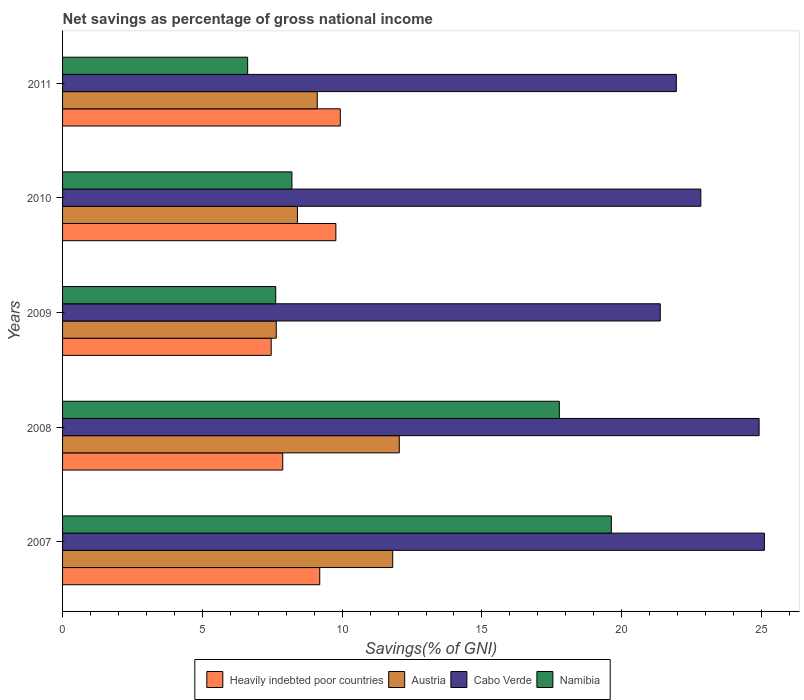How many different coloured bars are there?
Offer a very short reply. 4. Are the number of bars on each tick of the Y-axis equal?
Keep it short and to the point. Yes. How many bars are there on the 5th tick from the bottom?
Offer a very short reply. 4. What is the total savings in Cabo Verde in 2007?
Your answer should be compact. 25.1. Across all years, what is the maximum total savings in Namibia?
Make the answer very short. 19.63. Across all years, what is the minimum total savings in Heavily indebted poor countries?
Your answer should be compact. 7.46. What is the total total savings in Cabo Verde in the graph?
Keep it short and to the point. 116.18. What is the difference between the total savings in Cabo Verde in 2008 and that in 2009?
Keep it short and to the point. 3.54. What is the difference between the total savings in Cabo Verde in 2009 and the total savings in Austria in 2011?
Your answer should be compact. 12.27. What is the average total savings in Cabo Verde per year?
Offer a terse response. 23.24. In the year 2009, what is the difference between the total savings in Austria and total savings in Heavily indebted poor countries?
Your answer should be very brief. 0.18. In how many years, is the total savings in Heavily indebted poor countries greater than 4 %?
Provide a short and direct response. 5. What is the ratio of the total savings in Heavily indebted poor countries in 2007 to that in 2009?
Ensure brevity in your answer.  1.23. What is the difference between the highest and the second highest total savings in Heavily indebted poor countries?
Make the answer very short. 0.16. What is the difference between the highest and the lowest total savings in Namibia?
Make the answer very short. 13.01. Is the sum of the total savings in Cabo Verde in 2008 and 2009 greater than the maximum total savings in Austria across all years?
Your answer should be compact. Yes. Is it the case that in every year, the sum of the total savings in Austria and total savings in Cabo Verde is greater than the sum of total savings in Heavily indebted poor countries and total savings in Namibia?
Provide a succinct answer. Yes. What does the 2nd bar from the bottom in 2011 represents?
Ensure brevity in your answer.  Austria. How many bars are there?
Offer a very short reply. 20. Does the graph contain any zero values?
Provide a succinct answer. No. Does the graph contain grids?
Keep it short and to the point. No. How are the legend labels stacked?
Keep it short and to the point. Horizontal. What is the title of the graph?
Offer a very short reply. Net savings as percentage of gross national income. Does "Other small states" appear as one of the legend labels in the graph?
Provide a short and direct response. No. What is the label or title of the X-axis?
Your answer should be very brief. Savings(% of GNI). What is the label or title of the Y-axis?
Your answer should be compact. Years. What is the Savings(% of GNI) of Heavily indebted poor countries in 2007?
Offer a very short reply. 9.2. What is the Savings(% of GNI) of Austria in 2007?
Make the answer very short. 11.81. What is the Savings(% of GNI) of Cabo Verde in 2007?
Your answer should be very brief. 25.1. What is the Savings(% of GNI) of Namibia in 2007?
Offer a very short reply. 19.63. What is the Savings(% of GNI) of Heavily indebted poor countries in 2008?
Offer a terse response. 7.87. What is the Savings(% of GNI) in Austria in 2008?
Your answer should be compact. 12.04. What is the Savings(% of GNI) of Cabo Verde in 2008?
Give a very brief answer. 24.91. What is the Savings(% of GNI) of Namibia in 2008?
Keep it short and to the point. 17.77. What is the Savings(% of GNI) in Heavily indebted poor countries in 2009?
Offer a terse response. 7.46. What is the Savings(% of GNI) of Austria in 2009?
Your answer should be very brief. 7.64. What is the Savings(% of GNI) in Cabo Verde in 2009?
Offer a terse response. 21.38. What is the Savings(% of GNI) of Namibia in 2009?
Ensure brevity in your answer.  7.62. What is the Savings(% of GNI) of Heavily indebted poor countries in 2010?
Your answer should be very brief. 9.78. What is the Savings(% of GNI) of Austria in 2010?
Ensure brevity in your answer.  8.4. What is the Savings(% of GNI) of Cabo Verde in 2010?
Give a very brief answer. 22.83. What is the Savings(% of GNI) of Namibia in 2010?
Keep it short and to the point. 8.2. What is the Savings(% of GNI) of Heavily indebted poor countries in 2011?
Give a very brief answer. 9.93. What is the Savings(% of GNI) of Austria in 2011?
Offer a terse response. 9.11. What is the Savings(% of GNI) in Cabo Verde in 2011?
Ensure brevity in your answer.  21.95. What is the Savings(% of GNI) in Namibia in 2011?
Keep it short and to the point. 6.62. Across all years, what is the maximum Savings(% of GNI) in Heavily indebted poor countries?
Offer a very short reply. 9.93. Across all years, what is the maximum Savings(% of GNI) in Austria?
Offer a terse response. 12.04. Across all years, what is the maximum Savings(% of GNI) of Cabo Verde?
Offer a very short reply. 25.1. Across all years, what is the maximum Savings(% of GNI) in Namibia?
Your answer should be very brief. 19.63. Across all years, what is the minimum Savings(% of GNI) of Heavily indebted poor countries?
Your answer should be very brief. 7.46. Across all years, what is the minimum Savings(% of GNI) of Austria?
Give a very brief answer. 7.64. Across all years, what is the minimum Savings(% of GNI) of Cabo Verde?
Your answer should be compact. 21.38. Across all years, what is the minimum Savings(% of GNI) in Namibia?
Your answer should be compact. 6.62. What is the total Savings(% of GNI) in Heavily indebted poor countries in the graph?
Your response must be concise. 44.25. What is the total Savings(% of GNI) in Austria in the graph?
Provide a succinct answer. 49.01. What is the total Savings(% of GNI) in Cabo Verde in the graph?
Provide a short and direct response. 116.18. What is the total Savings(% of GNI) in Namibia in the graph?
Provide a short and direct response. 59.85. What is the difference between the Savings(% of GNI) in Heavily indebted poor countries in 2007 and that in 2008?
Ensure brevity in your answer.  1.32. What is the difference between the Savings(% of GNI) in Austria in 2007 and that in 2008?
Keep it short and to the point. -0.24. What is the difference between the Savings(% of GNI) in Cabo Verde in 2007 and that in 2008?
Provide a succinct answer. 0.19. What is the difference between the Savings(% of GNI) in Namibia in 2007 and that in 2008?
Provide a short and direct response. 1.86. What is the difference between the Savings(% of GNI) of Heavily indebted poor countries in 2007 and that in 2009?
Offer a terse response. 1.74. What is the difference between the Savings(% of GNI) of Austria in 2007 and that in 2009?
Give a very brief answer. 4.16. What is the difference between the Savings(% of GNI) in Cabo Verde in 2007 and that in 2009?
Offer a terse response. 3.72. What is the difference between the Savings(% of GNI) of Namibia in 2007 and that in 2009?
Make the answer very short. 12. What is the difference between the Savings(% of GNI) in Heavily indebted poor countries in 2007 and that in 2010?
Ensure brevity in your answer.  -0.58. What is the difference between the Savings(% of GNI) of Austria in 2007 and that in 2010?
Provide a short and direct response. 3.41. What is the difference between the Savings(% of GNI) in Cabo Verde in 2007 and that in 2010?
Make the answer very short. 2.27. What is the difference between the Savings(% of GNI) in Namibia in 2007 and that in 2010?
Give a very brief answer. 11.43. What is the difference between the Savings(% of GNI) of Heavily indebted poor countries in 2007 and that in 2011?
Your answer should be very brief. -0.73. What is the difference between the Savings(% of GNI) in Austria in 2007 and that in 2011?
Provide a succinct answer. 2.7. What is the difference between the Savings(% of GNI) in Cabo Verde in 2007 and that in 2011?
Provide a succinct answer. 3.15. What is the difference between the Savings(% of GNI) in Namibia in 2007 and that in 2011?
Your answer should be very brief. 13.01. What is the difference between the Savings(% of GNI) of Heavily indebted poor countries in 2008 and that in 2009?
Provide a succinct answer. 0.41. What is the difference between the Savings(% of GNI) of Austria in 2008 and that in 2009?
Make the answer very short. 4.4. What is the difference between the Savings(% of GNI) of Cabo Verde in 2008 and that in 2009?
Provide a succinct answer. 3.54. What is the difference between the Savings(% of GNI) in Namibia in 2008 and that in 2009?
Provide a short and direct response. 10.14. What is the difference between the Savings(% of GNI) in Heavily indebted poor countries in 2008 and that in 2010?
Provide a succinct answer. -1.9. What is the difference between the Savings(% of GNI) in Austria in 2008 and that in 2010?
Provide a short and direct response. 3.64. What is the difference between the Savings(% of GNI) of Cabo Verde in 2008 and that in 2010?
Give a very brief answer. 2.08. What is the difference between the Savings(% of GNI) in Namibia in 2008 and that in 2010?
Ensure brevity in your answer.  9.57. What is the difference between the Savings(% of GNI) in Heavily indebted poor countries in 2008 and that in 2011?
Make the answer very short. -2.06. What is the difference between the Savings(% of GNI) in Austria in 2008 and that in 2011?
Your answer should be very brief. 2.94. What is the difference between the Savings(% of GNI) in Cabo Verde in 2008 and that in 2011?
Provide a short and direct response. 2.96. What is the difference between the Savings(% of GNI) in Namibia in 2008 and that in 2011?
Your answer should be compact. 11.15. What is the difference between the Savings(% of GNI) in Heavily indebted poor countries in 2009 and that in 2010?
Give a very brief answer. -2.31. What is the difference between the Savings(% of GNI) in Austria in 2009 and that in 2010?
Provide a short and direct response. -0.76. What is the difference between the Savings(% of GNI) of Cabo Verde in 2009 and that in 2010?
Provide a succinct answer. -1.45. What is the difference between the Savings(% of GNI) of Namibia in 2009 and that in 2010?
Provide a short and direct response. -0.58. What is the difference between the Savings(% of GNI) of Heavily indebted poor countries in 2009 and that in 2011?
Your response must be concise. -2.47. What is the difference between the Savings(% of GNI) of Austria in 2009 and that in 2011?
Your answer should be compact. -1.47. What is the difference between the Savings(% of GNI) in Cabo Verde in 2009 and that in 2011?
Ensure brevity in your answer.  -0.57. What is the difference between the Savings(% of GNI) of Namibia in 2009 and that in 2011?
Your answer should be compact. 1. What is the difference between the Savings(% of GNI) in Heavily indebted poor countries in 2010 and that in 2011?
Provide a succinct answer. -0.16. What is the difference between the Savings(% of GNI) of Austria in 2010 and that in 2011?
Provide a succinct answer. -0.71. What is the difference between the Savings(% of GNI) in Cabo Verde in 2010 and that in 2011?
Keep it short and to the point. 0.88. What is the difference between the Savings(% of GNI) in Namibia in 2010 and that in 2011?
Offer a terse response. 1.58. What is the difference between the Savings(% of GNI) of Heavily indebted poor countries in 2007 and the Savings(% of GNI) of Austria in 2008?
Provide a short and direct response. -2.84. What is the difference between the Savings(% of GNI) of Heavily indebted poor countries in 2007 and the Savings(% of GNI) of Cabo Verde in 2008?
Your answer should be very brief. -15.72. What is the difference between the Savings(% of GNI) of Heavily indebted poor countries in 2007 and the Savings(% of GNI) of Namibia in 2008?
Make the answer very short. -8.57. What is the difference between the Savings(% of GNI) in Austria in 2007 and the Savings(% of GNI) in Cabo Verde in 2008?
Offer a very short reply. -13.11. What is the difference between the Savings(% of GNI) of Austria in 2007 and the Savings(% of GNI) of Namibia in 2008?
Offer a very short reply. -5.96. What is the difference between the Savings(% of GNI) of Cabo Verde in 2007 and the Savings(% of GNI) of Namibia in 2008?
Your response must be concise. 7.33. What is the difference between the Savings(% of GNI) in Heavily indebted poor countries in 2007 and the Savings(% of GNI) in Austria in 2009?
Keep it short and to the point. 1.56. What is the difference between the Savings(% of GNI) in Heavily indebted poor countries in 2007 and the Savings(% of GNI) in Cabo Verde in 2009?
Provide a short and direct response. -12.18. What is the difference between the Savings(% of GNI) of Heavily indebted poor countries in 2007 and the Savings(% of GNI) of Namibia in 2009?
Make the answer very short. 1.57. What is the difference between the Savings(% of GNI) in Austria in 2007 and the Savings(% of GNI) in Cabo Verde in 2009?
Give a very brief answer. -9.57. What is the difference between the Savings(% of GNI) of Austria in 2007 and the Savings(% of GNI) of Namibia in 2009?
Your response must be concise. 4.18. What is the difference between the Savings(% of GNI) in Cabo Verde in 2007 and the Savings(% of GNI) in Namibia in 2009?
Provide a succinct answer. 17.48. What is the difference between the Savings(% of GNI) of Heavily indebted poor countries in 2007 and the Savings(% of GNI) of Austria in 2010?
Your answer should be compact. 0.8. What is the difference between the Savings(% of GNI) of Heavily indebted poor countries in 2007 and the Savings(% of GNI) of Cabo Verde in 2010?
Offer a terse response. -13.63. What is the difference between the Savings(% of GNI) of Heavily indebted poor countries in 2007 and the Savings(% of GNI) of Namibia in 2010?
Your answer should be very brief. 1. What is the difference between the Savings(% of GNI) of Austria in 2007 and the Savings(% of GNI) of Cabo Verde in 2010?
Make the answer very short. -11.02. What is the difference between the Savings(% of GNI) in Austria in 2007 and the Savings(% of GNI) in Namibia in 2010?
Provide a succinct answer. 3.6. What is the difference between the Savings(% of GNI) in Cabo Verde in 2007 and the Savings(% of GNI) in Namibia in 2010?
Keep it short and to the point. 16.9. What is the difference between the Savings(% of GNI) of Heavily indebted poor countries in 2007 and the Savings(% of GNI) of Austria in 2011?
Ensure brevity in your answer.  0.09. What is the difference between the Savings(% of GNI) of Heavily indebted poor countries in 2007 and the Savings(% of GNI) of Cabo Verde in 2011?
Offer a terse response. -12.75. What is the difference between the Savings(% of GNI) of Heavily indebted poor countries in 2007 and the Savings(% of GNI) of Namibia in 2011?
Provide a succinct answer. 2.58. What is the difference between the Savings(% of GNI) of Austria in 2007 and the Savings(% of GNI) of Cabo Verde in 2011?
Provide a short and direct response. -10.14. What is the difference between the Savings(% of GNI) in Austria in 2007 and the Savings(% of GNI) in Namibia in 2011?
Your answer should be compact. 5.19. What is the difference between the Savings(% of GNI) in Cabo Verde in 2007 and the Savings(% of GNI) in Namibia in 2011?
Ensure brevity in your answer.  18.48. What is the difference between the Savings(% of GNI) in Heavily indebted poor countries in 2008 and the Savings(% of GNI) in Austria in 2009?
Your response must be concise. 0.23. What is the difference between the Savings(% of GNI) in Heavily indebted poor countries in 2008 and the Savings(% of GNI) in Cabo Verde in 2009?
Make the answer very short. -13.5. What is the difference between the Savings(% of GNI) of Heavily indebted poor countries in 2008 and the Savings(% of GNI) of Namibia in 2009?
Provide a succinct answer. 0.25. What is the difference between the Savings(% of GNI) of Austria in 2008 and the Savings(% of GNI) of Cabo Verde in 2009?
Your answer should be compact. -9.33. What is the difference between the Savings(% of GNI) in Austria in 2008 and the Savings(% of GNI) in Namibia in 2009?
Keep it short and to the point. 4.42. What is the difference between the Savings(% of GNI) of Cabo Verde in 2008 and the Savings(% of GNI) of Namibia in 2009?
Offer a terse response. 17.29. What is the difference between the Savings(% of GNI) of Heavily indebted poor countries in 2008 and the Savings(% of GNI) of Austria in 2010?
Keep it short and to the point. -0.53. What is the difference between the Savings(% of GNI) of Heavily indebted poor countries in 2008 and the Savings(% of GNI) of Cabo Verde in 2010?
Your answer should be compact. -14.95. What is the difference between the Savings(% of GNI) of Heavily indebted poor countries in 2008 and the Savings(% of GNI) of Namibia in 2010?
Offer a terse response. -0.33. What is the difference between the Savings(% of GNI) in Austria in 2008 and the Savings(% of GNI) in Cabo Verde in 2010?
Ensure brevity in your answer.  -10.79. What is the difference between the Savings(% of GNI) of Austria in 2008 and the Savings(% of GNI) of Namibia in 2010?
Keep it short and to the point. 3.84. What is the difference between the Savings(% of GNI) in Cabo Verde in 2008 and the Savings(% of GNI) in Namibia in 2010?
Your answer should be very brief. 16.71. What is the difference between the Savings(% of GNI) of Heavily indebted poor countries in 2008 and the Savings(% of GNI) of Austria in 2011?
Keep it short and to the point. -1.23. What is the difference between the Savings(% of GNI) of Heavily indebted poor countries in 2008 and the Savings(% of GNI) of Cabo Verde in 2011?
Your response must be concise. -14.08. What is the difference between the Savings(% of GNI) of Heavily indebted poor countries in 2008 and the Savings(% of GNI) of Namibia in 2011?
Ensure brevity in your answer.  1.25. What is the difference between the Savings(% of GNI) of Austria in 2008 and the Savings(% of GNI) of Cabo Verde in 2011?
Give a very brief answer. -9.91. What is the difference between the Savings(% of GNI) of Austria in 2008 and the Savings(% of GNI) of Namibia in 2011?
Offer a terse response. 5.42. What is the difference between the Savings(% of GNI) of Cabo Verde in 2008 and the Savings(% of GNI) of Namibia in 2011?
Provide a short and direct response. 18.29. What is the difference between the Savings(% of GNI) of Heavily indebted poor countries in 2009 and the Savings(% of GNI) of Austria in 2010?
Ensure brevity in your answer.  -0.94. What is the difference between the Savings(% of GNI) of Heavily indebted poor countries in 2009 and the Savings(% of GNI) of Cabo Verde in 2010?
Make the answer very short. -15.37. What is the difference between the Savings(% of GNI) in Heavily indebted poor countries in 2009 and the Savings(% of GNI) in Namibia in 2010?
Your answer should be compact. -0.74. What is the difference between the Savings(% of GNI) in Austria in 2009 and the Savings(% of GNI) in Cabo Verde in 2010?
Your response must be concise. -15.19. What is the difference between the Savings(% of GNI) in Austria in 2009 and the Savings(% of GNI) in Namibia in 2010?
Provide a short and direct response. -0.56. What is the difference between the Savings(% of GNI) in Cabo Verde in 2009 and the Savings(% of GNI) in Namibia in 2010?
Your answer should be very brief. 13.18. What is the difference between the Savings(% of GNI) of Heavily indebted poor countries in 2009 and the Savings(% of GNI) of Austria in 2011?
Make the answer very short. -1.65. What is the difference between the Savings(% of GNI) of Heavily indebted poor countries in 2009 and the Savings(% of GNI) of Cabo Verde in 2011?
Offer a terse response. -14.49. What is the difference between the Savings(% of GNI) of Heavily indebted poor countries in 2009 and the Savings(% of GNI) of Namibia in 2011?
Provide a succinct answer. 0.84. What is the difference between the Savings(% of GNI) of Austria in 2009 and the Savings(% of GNI) of Cabo Verde in 2011?
Give a very brief answer. -14.31. What is the difference between the Savings(% of GNI) in Austria in 2009 and the Savings(% of GNI) in Namibia in 2011?
Offer a very short reply. 1.02. What is the difference between the Savings(% of GNI) of Cabo Verde in 2009 and the Savings(% of GNI) of Namibia in 2011?
Provide a succinct answer. 14.76. What is the difference between the Savings(% of GNI) in Heavily indebted poor countries in 2010 and the Savings(% of GNI) in Austria in 2011?
Provide a succinct answer. 0.67. What is the difference between the Savings(% of GNI) in Heavily indebted poor countries in 2010 and the Savings(% of GNI) in Cabo Verde in 2011?
Your answer should be compact. -12.18. What is the difference between the Savings(% of GNI) of Heavily indebted poor countries in 2010 and the Savings(% of GNI) of Namibia in 2011?
Give a very brief answer. 3.16. What is the difference between the Savings(% of GNI) of Austria in 2010 and the Savings(% of GNI) of Cabo Verde in 2011?
Offer a terse response. -13.55. What is the difference between the Savings(% of GNI) in Austria in 2010 and the Savings(% of GNI) in Namibia in 2011?
Make the answer very short. 1.78. What is the difference between the Savings(% of GNI) of Cabo Verde in 2010 and the Savings(% of GNI) of Namibia in 2011?
Your response must be concise. 16.21. What is the average Savings(% of GNI) of Heavily indebted poor countries per year?
Ensure brevity in your answer.  8.85. What is the average Savings(% of GNI) in Austria per year?
Make the answer very short. 9.8. What is the average Savings(% of GNI) of Cabo Verde per year?
Offer a very short reply. 23.24. What is the average Savings(% of GNI) of Namibia per year?
Provide a short and direct response. 11.97. In the year 2007, what is the difference between the Savings(% of GNI) in Heavily indebted poor countries and Savings(% of GNI) in Austria?
Ensure brevity in your answer.  -2.61. In the year 2007, what is the difference between the Savings(% of GNI) of Heavily indebted poor countries and Savings(% of GNI) of Cabo Verde?
Make the answer very short. -15.9. In the year 2007, what is the difference between the Savings(% of GNI) in Heavily indebted poor countries and Savings(% of GNI) in Namibia?
Provide a short and direct response. -10.43. In the year 2007, what is the difference between the Savings(% of GNI) in Austria and Savings(% of GNI) in Cabo Verde?
Your response must be concise. -13.3. In the year 2007, what is the difference between the Savings(% of GNI) in Austria and Savings(% of GNI) in Namibia?
Give a very brief answer. -7.82. In the year 2007, what is the difference between the Savings(% of GNI) in Cabo Verde and Savings(% of GNI) in Namibia?
Make the answer very short. 5.47. In the year 2008, what is the difference between the Savings(% of GNI) of Heavily indebted poor countries and Savings(% of GNI) of Austria?
Keep it short and to the point. -4.17. In the year 2008, what is the difference between the Savings(% of GNI) in Heavily indebted poor countries and Savings(% of GNI) in Cabo Verde?
Give a very brief answer. -17.04. In the year 2008, what is the difference between the Savings(% of GNI) of Heavily indebted poor countries and Savings(% of GNI) of Namibia?
Provide a short and direct response. -9.89. In the year 2008, what is the difference between the Savings(% of GNI) in Austria and Savings(% of GNI) in Cabo Verde?
Your answer should be very brief. -12.87. In the year 2008, what is the difference between the Savings(% of GNI) in Austria and Savings(% of GNI) in Namibia?
Ensure brevity in your answer.  -5.73. In the year 2008, what is the difference between the Savings(% of GNI) of Cabo Verde and Savings(% of GNI) of Namibia?
Offer a very short reply. 7.15. In the year 2009, what is the difference between the Savings(% of GNI) of Heavily indebted poor countries and Savings(% of GNI) of Austria?
Your answer should be very brief. -0.18. In the year 2009, what is the difference between the Savings(% of GNI) in Heavily indebted poor countries and Savings(% of GNI) in Cabo Verde?
Offer a very short reply. -13.92. In the year 2009, what is the difference between the Savings(% of GNI) in Heavily indebted poor countries and Savings(% of GNI) in Namibia?
Your answer should be compact. -0.16. In the year 2009, what is the difference between the Savings(% of GNI) of Austria and Savings(% of GNI) of Cabo Verde?
Give a very brief answer. -13.74. In the year 2009, what is the difference between the Savings(% of GNI) of Austria and Savings(% of GNI) of Namibia?
Give a very brief answer. 0.02. In the year 2009, what is the difference between the Savings(% of GNI) of Cabo Verde and Savings(% of GNI) of Namibia?
Make the answer very short. 13.75. In the year 2010, what is the difference between the Savings(% of GNI) in Heavily indebted poor countries and Savings(% of GNI) in Austria?
Your answer should be very brief. 1.37. In the year 2010, what is the difference between the Savings(% of GNI) of Heavily indebted poor countries and Savings(% of GNI) of Cabo Verde?
Ensure brevity in your answer.  -13.05. In the year 2010, what is the difference between the Savings(% of GNI) in Heavily indebted poor countries and Savings(% of GNI) in Namibia?
Your answer should be very brief. 1.57. In the year 2010, what is the difference between the Savings(% of GNI) of Austria and Savings(% of GNI) of Cabo Verde?
Offer a terse response. -14.43. In the year 2010, what is the difference between the Savings(% of GNI) of Austria and Savings(% of GNI) of Namibia?
Make the answer very short. 0.2. In the year 2010, what is the difference between the Savings(% of GNI) in Cabo Verde and Savings(% of GNI) in Namibia?
Your answer should be compact. 14.63. In the year 2011, what is the difference between the Savings(% of GNI) of Heavily indebted poor countries and Savings(% of GNI) of Austria?
Make the answer very short. 0.82. In the year 2011, what is the difference between the Savings(% of GNI) in Heavily indebted poor countries and Savings(% of GNI) in Cabo Verde?
Ensure brevity in your answer.  -12.02. In the year 2011, what is the difference between the Savings(% of GNI) in Heavily indebted poor countries and Savings(% of GNI) in Namibia?
Your answer should be compact. 3.31. In the year 2011, what is the difference between the Savings(% of GNI) of Austria and Savings(% of GNI) of Cabo Verde?
Your answer should be compact. -12.84. In the year 2011, what is the difference between the Savings(% of GNI) of Austria and Savings(% of GNI) of Namibia?
Make the answer very short. 2.49. In the year 2011, what is the difference between the Savings(% of GNI) of Cabo Verde and Savings(% of GNI) of Namibia?
Provide a short and direct response. 15.33. What is the ratio of the Savings(% of GNI) of Heavily indebted poor countries in 2007 to that in 2008?
Ensure brevity in your answer.  1.17. What is the ratio of the Savings(% of GNI) of Austria in 2007 to that in 2008?
Offer a terse response. 0.98. What is the ratio of the Savings(% of GNI) of Cabo Verde in 2007 to that in 2008?
Make the answer very short. 1.01. What is the ratio of the Savings(% of GNI) of Namibia in 2007 to that in 2008?
Your answer should be very brief. 1.1. What is the ratio of the Savings(% of GNI) in Heavily indebted poor countries in 2007 to that in 2009?
Your answer should be very brief. 1.23. What is the ratio of the Savings(% of GNI) of Austria in 2007 to that in 2009?
Ensure brevity in your answer.  1.54. What is the ratio of the Savings(% of GNI) in Cabo Verde in 2007 to that in 2009?
Provide a short and direct response. 1.17. What is the ratio of the Savings(% of GNI) in Namibia in 2007 to that in 2009?
Your answer should be compact. 2.57. What is the ratio of the Savings(% of GNI) of Heavily indebted poor countries in 2007 to that in 2010?
Provide a short and direct response. 0.94. What is the ratio of the Savings(% of GNI) in Austria in 2007 to that in 2010?
Your answer should be very brief. 1.41. What is the ratio of the Savings(% of GNI) of Cabo Verde in 2007 to that in 2010?
Provide a succinct answer. 1.1. What is the ratio of the Savings(% of GNI) in Namibia in 2007 to that in 2010?
Your answer should be very brief. 2.39. What is the ratio of the Savings(% of GNI) of Heavily indebted poor countries in 2007 to that in 2011?
Make the answer very short. 0.93. What is the ratio of the Savings(% of GNI) of Austria in 2007 to that in 2011?
Offer a terse response. 1.3. What is the ratio of the Savings(% of GNI) in Cabo Verde in 2007 to that in 2011?
Make the answer very short. 1.14. What is the ratio of the Savings(% of GNI) in Namibia in 2007 to that in 2011?
Ensure brevity in your answer.  2.96. What is the ratio of the Savings(% of GNI) in Heavily indebted poor countries in 2008 to that in 2009?
Ensure brevity in your answer.  1.06. What is the ratio of the Savings(% of GNI) in Austria in 2008 to that in 2009?
Your response must be concise. 1.58. What is the ratio of the Savings(% of GNI) in Cabo Verde in 2008 to that in 2009?
Your answer should be compact. 1.17. What is the ratio of the Savings(% of GNI) of Namibia in 2008 to that in 2009?
Make the answer very short. 2.33. What is the ratio of the Savings(% of GNI) in Heavily indebted poor countries in 2008 to that in 2010?
Make the answer very short. 0.81. What is the ratio of the Savings(% of GNI) of Austria in 2008 to that in 2010?
Your answer should be compact. 1.43. What is the ratio of the Savings(% of GNI) of Cabo Verde in 2008 to that in 2010?
Your answer should be very brief. 1.09. What is the ratio of the Savings(% of GNI) in Namibia in 2008 to that in 2010?
Provide a succinct answer. 2.17. What is the ratio of the Savings(% of GNI) in Heavily indebted poor countries in 2008 to that in 2011?
Make the answer very short. 0.79. What is the ratio of the Savings(% of GNI) of Austria in 2008 to that in 2011?
Offer a terse response. 1.32. What is the ratio of the Savings(% of GNI) of Cabo Verde in 2008 to that in 2011?
Your answer should be compact. 1.13. What is the ratio of the Savings(% of GNI) in Namibia in 2008 to that in 2011?
Ensure brevity in your answer.  2.68. What is the ratio of the Savings(% of GNI) of Heavily indebted poor countries in 2009 to that in 2010?
Keep it short and to the point. 0.76. What is the ratio of the Savings(% of GNI) of Austria in 2009 to that in 2010?
Your answer should be very brief. 0.91. What is the ratio of the Savings(% of GNI) of Cabo Verde in 2009 to that in 2010?
Offer a very short reply. 0.94. What is the ratio of the Savings(% of GNI) of Namibia in 2009 to that in 2010?
Make the answer very short. 0.93. What is the ratio of the Savings(% of GNI) in Heavily indebted poor countries in 2009 to that in 2011?
Offer a very short reply. 0.75. What is the ratio of the Savings(% of GNI) in Austria in 2009 to that in 2011?
Your answer should be very brief. 0.84. What is the ratio of the Savings(% of GNI) in Cabo Verde in 2009 to that in 2011?
Keep it short and to the point. 0.97. What is the ratio of the Savings(% of GNI) in Namibia in 2009 to that in 2011?
Offer a terse response. 1.15. What is the ratio of the Savings(% of GNI) of Heavily indebted poor countries in 2010 to that in 2011?
Your answer should be very brief. 0.98. What is the ratio of the Savings(% of GNI) of Austria in 2010 to that in 2011?
Give a very brief answer. 0.92. What is the ratio of the Savings(% of GNI) of Cabo Verde in 2010 to that in 2011?
Your response must be concise. 1.04. What is the ratio of the Savings(% of GNI) of Namibia in 2010 to that in 2011?
Give a very brief answer. 1.24. What is the difference between the highest and the second highest Savings(% of GNI) in Heavily indebted poor countries?
Your response must be concise. 0.16. What is the difference between the highest and the second highest Savings(% of GNI) in Austria?
Offer a terse response. 0.24. What is the difference between the highest and the second highest Savings(% of GNI) of Cabo Verde?
Ensure brevity in your answer.  0.19. What is the difference between the highest and the second highest Savings(% of GNI) of Namibia?
Provide a succinct answer. 1.86. What is the difference between the highest and the lowest Savings(% of GNI) in Heavily indebted poor countries?
Give a very brief answer. 2.47. What is the difference between the highest and the lowest Savings(% of GNI) of Austria?
Provide a succinct answer. 4.4. What is the difference between the highest and the lowest Savings(% of GNI) in Cabo Verde?
Provide a succinct answer. 3.72. What is the difference between the highest and the lowest Savings(% of GNI) of Namibia?
Your answer should be compact. 13.01. 